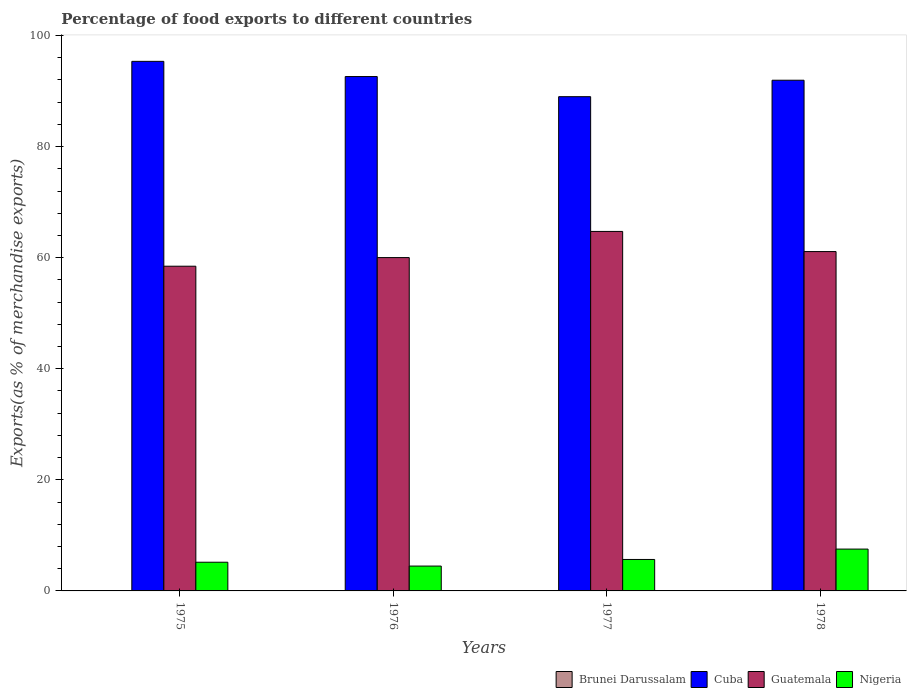How many groups of bars are there?
Provide a short and direct response. 4. Are the number of bars per tick equal to the number of legend labels?
Provide a short and direct response. Yes. Are the number of bars on each tick of the X-axis equal?
Give a very brief answer. Yes. What is the label of the 4th group of bars from the left?
Ensure brevity in your answer.  1978. In how many cases, is the number of bars for a given year not equal to the number of legend labels?
Ensure brevity in your answer.  0. What is the percentage of exports to different countries in Cuba in 1977?
Offer a terse response. 88.99. Across all years, what is the maximum percentage of exports to different countries in Brunei Darussalam?
Ensure brevity in your answer.  0.06. Across all years, what is the minimum percentage of exports to different countries in Cuba?
Make the answer very short. 88.99. In which year was the percentage of exports to different countries in Cuba maximum?
Provide a succinct answer. 1975. In which year was the percentage of exports to different countries in Nigeria minimum?
Provide a short and direct response. 1976. What is the total percentage of exports to different countries in Nigeria in the graph?
Offer a very short reply. 22.84. What is the difference between the percentage of exports to different countries in Cuba in 1975 and that in 1976?
Provide a short and direct response. 2.74. What is the difference between the percentage of exports to different countries in Brunei Darussalam in 1975 and the percentage of exports to different countries in Cuba in 1978?
Give a very brief answer. -91.89. What is the average percentage of exports to different countries in Cuba per year?
Your answer should be very brief. 92.23. In the year 1975, what is the difference between the percentage of exports to different countries in Guatemala and percentage of exports to different countries in Brunei Darussalam?
Your answer should be very brief. 58.4. In how many years, is the percentage of exports to different countries in Cuba greater than 40 %?
Your answer should be very brief. 4. What is the ratio of the percentage of exports to different countries in Guatemala in 1976 to that in 1978?
Offer a terse response. 0.98. Is the difference between the percentage of exports to different countries in Guatemala in 1975 and 1978 greater than the difference between the percentage of exports to different countries in Brunei Darussalam in 1975 and 1978?
Ensure brevity in your answer.  No. What is the difference between the highest and the second highest percentage of exports to different countries in Cuba?
Offer a terse response. 2.74. What is the difference between the highest and the lowest percentage of exports to different countries in Nigeria?
Give a very brief answer. 3.06. In how many years, is the percentage of exports to different countries in Cuba greater than the average percentage of exports to different countries in Cuba taken over all years?
Your answer should be very brief. 2. Is it the case that in every year, the sum of the percentage of exports to different countries in Guatemala and percentage of exports to different countries in Brunei Darussalam is greater than the sum of percentage of exports to different countries in Cuba and percentage of exports to different countries in Nigeria?
Offer a terse response. Yes. What does the 4th bar from the left in 1978 represents?
Provide a succinct answer. Nigeria. What does the 1st bar from the right in 1975 represents?
Offer a terse response. Nigeria. Is it the case that in every year, the sum of the percentage of exports to different countries in Guatemala and percentage of exports to different countries in Brunei Darussalam is greater than the percentage of exports to different countries in Nigeria?
Provide a succinct answer. Yes. How many bars are there?
Ensure brevity in your answer.  16. How many years are there in the graph?
Your answer should be compact. 4. Are the values on the major ticks of Y-axis written in scientific E-notation?
Make the answer very short. No. How many legend labels are there?
Your answer should be compact. 4. What is the title of the graph?
Provide a short and direct response. Percentage of food exports to different countries. What is the label or title of the X-axis?
Your response must be concise. Years. What is the label or title of the Y-axis?
Your response must be concise. Exports(as % of merchandise exports). What is the Exports(as % of merchandise exports) of Brunei Darussalam in 1975?
Make the answer very short. 0.06. What is the Exports(as % of merchandise exports) of Cuba in 1975?
Offer a very short reply. 95.35. What is the Exports(as % of merchandise exports) of Guatemala in 1975?
Make the answer very short. 58.47. What is the Exports(as % of merchandise exports) of Nigeria in 1975?
Your response must be concise. 5.17. What is the Exports(as % of merchandise exports) in Brunei Darussalam in 1976?
Provide a succinct answer. 0.04. What is the Exports(as % of merchandise exports) of Cuba in 1976?
Your answer should be compact. 92.62. What is the Exports(as % of merchandise exports) of Guatemala in 1976?
Offer a terse response. 60.02. What is the Exports(as % of merchandise exports) of Nigeria in 1976?
Offer a terse response. 4.47. What is the Exports(as % of merchandise exports) of Brunei Darussalam in 1977?
Your answer should be compact. 0.03. What is the Exports(as % of merchandise exports) of Cuba in 1977?
Your answer should be compact. 88.99. What is the Exports(as % of merchandise exports) in Guatemala in 1977?
Make the answer very short. 64.73. What is the Exports(as % of merchandise exports) in Nigeria in 1977?
Your answer should be very brief. 5.66. What is the Exports(as % of merchandise exports) of Brunei Darussalam in 1978?
Provide a succinct answer. 0.01. What is the Exports(as % of merchandise exports) of Cuba in 1978?
Keep it short and to the point. 91.95. What is the Exports(as % of merchandise exports) of Guatemala in 1978?
Provide a succinct answer. 61.1. What is the Exports(as % of merchandise exports) of Nigeria in 1978?
Ensure brevity in your answer.  7.53. Across all years, what is the maximum Exports(as % of merchandise exports) of Brunei Darussalam?
Ensure brevity in your answer.  0.06. Across all years, what is the maximum Exports(as % of merchandise exports) of Cuba?
Keep it short and to the point. 95.35. Across all years, what is the maximum Exports(as % of merchandise exports) of Guatemala?
Give a very brief answer. 64.73. Across all years, what is the maximum Exports(as % of merchandise exports) of Nigeria?
Provide a short and direct response. 7.53. Across all years, what is the minimum Exports(as % of merchandise exports) in Brunei Darussalam?
Make the answer very short. 0.01. Across all years, what is the minimum Exports(as % of merchandise exports) in Cuba?
Your answer should be very brief. 88.99. Across all years, what is the minimum Exports(as % of merchandise exports) of Guatemala?
Your answer should be very brief. 58.47. Across all years, what is the minimum Exports(as % of merchandise exports) of Nigeria?
Your answer should be compact. 4.47. What is the total Exports(as % of merchandise exports) of Brunei Darussalam in the graph?
Provide a succinct answer. 0.14. What is the total Exports(as % of merchandise exports) in Cuba in the graph?
Offer a terse response. 368.91. What is the total Exports(as % of merchandise exports) in Guatemala in the graph?
Keep it short and to the point. 244.32. What is the total Exports(as % of merchandise exports) of Nigeria in the graph?
Keep it short and to the point. 22.84. What is the difference between the Exports(as % of merchandise exports) of Brunei Darussalam in 1975 and that in 1976?
Your response must be concise. 0.03. What is the difference between the Exports(as % of merchandise exports) of Cuba in 1975 and that in 1976?
Your answer should be compact. 2.74. What is the difference between the Exports(as % of merchandise exports) of Guatemala in 1975 and that in 1976?
Provide a succinct answer. -1.55. What is the difference between the Exports(as % of merchandise exports) in Nigeria in 1975 and that in 1976?
Give a very brief answer. 0.69. What is the difference between the Exports(as % of merchandise exports) of Brunei Darussalam in 1975 and that in 1977?
Offer a very short reply. 0.04. What is the difference between the Exports(as % of merchandise exports) in Cuba in 1975 and that in 1977?
Your response must be concise. 6.36. What is the difference between the Exports(as % of merchandise exports) in Guatemala in 1975 and that in 1977?
Your response must be concise. -6.26. What is the difference between the Exports(as % of merchandise exports) of Nigeria in 1975 and that in 1977?
Ensure brevity in your answer.  -0.5. What is the difference between the Exports(as % of merchandise exports) in Brunei Darussalam in 1975 and that in 1978?
Your response must be concise. 0.05. What is the difference between the Exports(as % of merchandise exports) of Cuba in 1975 and that in 1978?
Provide a succinct answer. 3.4. What is the difference between the Exports(as % of merchandise exports) of Guatemala in 1975 and that in 1978?
Ensure brevity in your answer.  -2.64. What is the difference between the Exports(as % of merchandise exports) of Nigeria in 1975 and that in 1978?
Ensure brevity in your answer.  -2.37. What is the difference between the Exports(as % of merchandise exports) in Brunei Darussalam in 1976 and that in 1977?
Provide a short and direct response. 0.01. What is the difference between the Exports(as % of merchandise exports) of Cuba in 1976 and that in 1977?
Your response must be concise. 3.62. What is the difference between the Exports(as % of merchandise exports) of Guatemala in 1976 and that in 1977?
Your answer should be compact. -4.71. What is the difference between the Exports(as % of merchandise exports) in Nigeria in 1976 and that in 1977?
Offer a very short reply. -1.19. What is the difference between the Exports(as % of merchandise exports) of Brunei Darussalam in 1976 and that in 1978?
Keep it short and to the point. 0.02. What is the difference between the Exports(as % of merchandise exports) of Cuba in 1976 and that in 1978?
Your answer should be compact. 0.66. What is the difference between the Exports(as % of merchandise exports) of Guatemala in 1976 and that in 1978?
Your answer should be compact. -1.08. What is the difference between the Exports(as % of merchandise exports) in Nigeria in 1976 and that in 1978?
Offer a terse response. -3.06. What is the difference between the Exports(as % of merchandise exports) of Brunei Darussalam in 1977 and that in 1978?
Your answer should be very brief. 0.01. What is the difference between the Exports(as % of merchandise exports) in Cuba in 1977 and that in 1978?
Give a very brief answer. -2.96. What is the difference between the Exports(as % of merchandise exports) of Guatemala in 1977 and that in 1978?
Give a very brief answer. 3.62. What is the difference between the Exports(as % of merchandise exports) of Nigeria in 1977 and that in 1978?
Keep it short and to the point. -1.87. What is the difference between the Exports(as % of merchandise exports) in Brunei Darussalam in 1975 and the Exports(as % of merchandise exports) in Cuba in 1976?
Your answer should be very brief. -92.55. What is the difference between the Exports(as % of merchandise exports) in Brunei Darussalam in 1975 and the Exports(as % of merchandise exports) in Guatemala in 1976?
Provide a succinct answer. -59.96. What is the difference between the Exports(as % of merchandise exports) in Brunei Darussalam in 1975 and the Exports(as % of merchandise exports) in Nigeria in 1976?
Provide a short and direct response. -4.41. What is the difference between the Exports(as % of merchandise exports) of Cuba in 1975 and the Exports(as % of merchandise exports) of Guatemala in 1976?
Give a very brief answer. 35.33. What is the difference between the Exports(as % of merchandise exports) in Cuba in 1975 and the Exports(as % of merchandise exports) in Nigeria in 1976?
Your response must be concise. 90.88. What is the difference between the Exports(as % of merchandise exports) in Guatemala in 1975 and the Exports(as % of merchandise exports) in Nigeria in 1976?
Make the answer very short. 53.99. What is the difference between the Exports(as % of merchandise exports) of Brunei Darussalam in 1975 and the Exports(as % of merchandise exports) of Cuba in 1977?
Keep it short and to the point. -88.93. What is the difference between the Exports(as % of merchandise exports) of Brunei Darussalam in 1975 and the Exports(as % of merchandise exports) of Guatemala in 1977?
Offer a terse response. -64.66. What is the difference between the Exports(as % of merchandise exports) in Brunei Darussalam in 1975 and the Exports(as % of merchandise exports) in Nigeria in 1977?
Your answer should be compact. -5.6. What is the difference between the Exports(as % of merchandise exports) in Cuba in 1975 and the Exports(as % of merchandise exports) in Guatemala in 1977?
Provide a short and direct response. 30.62. What is the difference between the Exports(as % of merchandise exports) of Cuba in 1975 and the Exports(as % of merchandise exports) of Nigeria in 1977?
Make the answer very short. 89.69. What is the difference between the Exports(as % of merchandise exports) of Guatemala in 1975 and the Exports(as % of merchandise exports) of Nigeria in 1977?
Offer a very short reply. 52.8. What is the difference between the Exports(as % of merchandise exports) in Brunei Darussalam in 1975 and the Exports(as % of merchandise exports) in Cuba in 1978?
Ensure brevity in your answer.  -91.89. What is the difference between the Exports(as % of merchandise exports) in Brunei Darussalam in 1975 and the Exports(as % of merchandise exports) in Guatemala in 1978?
Ensure brevity in your answer.  -61.04. What is the difference between the Exports(as % of merchandise exports) in Brunei Darussalam in 1975 and the Exports(as % of merchandise exports) in Nigeria in 1978?
Your answer should be compact. -7.47. What is the difference between the Exports(as % of merchandise exports) in Cuba in 1975 and the Exports(as % of merchandise exports) in Guatemala in 1978?
Your response must be concise. 34.25. What is the difference between the Exports(as % of merchandise exports) of Cuba in 1975 and the Exports(as % of merchandise exports) of Nigeria in 1978?
Provide a short and direct response. 87.82. What is the difference between the Exports(as % of merchandise exports) of Guatemala in 1975 and the Exports(as % of merchandise exports) of Nigeria in 1978?
Your answer should be very brief. 50.94. What is the difference between the Exports(as % of merchandise exports) of Brunei Darussalam in 1976 and the Exports(as % of merchandise exports) of Cuba in 1977?
Your answer should be very brief. -88.96. What is the difference between the Exports(as % of merchandise exports) in Brunei Darussalam in 1976 and the Exports(as % of merchandise exports) in Guatemala in 1977?
Your answer should be very brief. -64.69. What is the difference between the Exports(as % of merchandise exports) of Brunei Darussalam in 1976 and the Exports(as % of merchandise exports) of Nigeria in 1977?
Offer a terse response. -5.63. What is the difference between the Exports(as % of merchandise exports) of Cuba in 1976 and the Exports(as % of merchandise exports) of Guatemala in 1977?
Your response must be concise. 27.89. What is the difference between the Exports(as % of merchandise exports) of Cuba in 1976 and the Exports(as % of merchandise exports) of Nigeria in 1977?
Your answer should be compact. 86.95. What is the difference between the Exports(as % of merchandise exports) in Guatemala in 1976 and the Exports(as % of merchandise exports) in Nigeria in 1977?
Provide a short and direct response. 54.36. What is the difference between the Exports(as % of merchandise exports) in Brunei Darussalam in 1976 and the Exports(as % of merchandise exports) in Cuba in 1978?
Ensure brevity in your answer.  -91.92. What is the difference between the Exports(as % of merchandise exports) in Brunei Darussalam in 1976 and the Exports(as % of merchandise exports) in Guatemala in 1978?
Provide a succinct answer. -61.07. What is the difference between the Exports(as % of merchandise exports) in Brunei Darussalam in 1976 and the Exports(as % of merchandise exports) in Nigeria in 1978?
Your answer should be very brief. -7.5. What is the difference between the Exports(as % of merchandise exports) in Cuba in 1976 and the Exports(as % of merchandise exports) in Guatemala in 1978?
Provide a short and direct response. 31.51. What is the difference between the Exports(as % of merchandise exports) of Cuba in 1976 and the Exports(as % of merchandise exports) of Nigeria in 1978?
Provide a succinct answer. 85.08. What is the difference between the Exports(as % of merchandise exports) in Guatemala in 1976 and the Exports(as % of merchandise exports) in Nigeria in 1978?
Your answer should be very brief. 52.49. What is the difference between the Exports(as % of merchandise exports) in Brunei Darussalam in 1977 and the Exports(as % of merchandise exports) in Cuba in 1978?
Make the answer very short. -91.92. What is the difference between the Exports(as % of merchandise exports) in Brunei Darussalam in 1977 and the Exports(as % of merchandise exports) in Guatemala in 1978?
Your answer should be compact. -61.08. What is the difference between the Exports(as % of merchandise exports) in Brunei Darussalam in 1977 and the Exports(as % of merchandise exports) in Nigeria in 1978?
Make the answer very short. -7.5. What is the difference between the Exports(as % of merchandise exports) in Cuba in 1977 and the Exports(as % of merchandise exports) in Guatemala in 1978?
Offer a terse response. 27.89. What is the difference between the Exports(as % of merchandise exports) of Cuba in 1977 and the Exports(as % of merchandise exports) of Nigeria in 1978?
Provide a short and direct response. 81.46. What is the difference between the Exports(as % of merchandise exports) in Guatemala in 1977 and the Exports(as % of merchandise exports) in Nigeria in 1978?
Make the answer very short. 57.2. What is the average Exports(as % of merchandise exports) in Brunei Darussalam per year?
Offer a very short reply. 0.04. What is the average Exports(as % of merchandise exports) of Cuba per year?
Your answer should be compact. 92.23. What is the average Exports(as % of merchandise exports) in Guatemala per year?
Make the answer very short. 61.08. What is the average Exports(as % of merchandise exports) in Nigeria per year?
Offer a terse response. 5.71. In the year 1975, what is the difference between the Exports(as % of merchandise exports) in Brunei Darussalam and Exports(as % of merchandise exports) in Cuba?
Offer a very short reply. -95.29. In the year 1975, what is the difference between the Exports(as % of merchandise exports) in Brunei Darussalam and Exports(as % of merchandise exports) in Guatemala?
Provide a short and direct response. -58.4. In the year 1975, what is the difference between the Exports(as % of merchandise exports) in Brunei Darussalam and Exports(as % of merchandise exports) in Nigeria?
Keep it short and to the point. -5.1. In the year 1975, what is the difference between the Exports(as % of merchandise exports) of Cuba and Exports(as % of merchandise exports) of Guatemala?
Offer a very short reply. 36.88. In the year 1975, what is the difference between the Exports(as % of merchandise exports) in Cuba and Exports(as % of merchandise exports) in Nigeria?
Make the answer very short. 90.19. In the year 1975, what is the difference between the Exports(as % of merchandise exports) in Guatemala and Exports(as % of merchandise exports) in Nigeria?
Make the answer very short. 53.3. In the year 1976, what is the difference between the Exports(as % of merchandise exports) in Brunei Darussalam and Exports(as % of merchandise exports) in Cuba?
Offer a very short reply. -92.58. In the year 1976, what is the difference between the Exports(as % of merchandise exports) of Brunei Darussalam and Exports(as % of merchandise exports) of Guatemala?
Ensure brevity in your answer.  -59.98. In the year 1976, what is the difference between the Exports(as % of merchandise exports) of Brunei Darussalam and Exports(as % of merchandise exports) of Nigeria?
Offer a very short reply. -4.44. In the year 1976, what is the difference between the Exports(as % of merchandise exports) of Cuba and Exports(as % of merchandise exports) of Guatemala?
Keep it short and to the point. 32.6. In the year 1976, what is the difference between the Exports(as % of merchandise exports) of Cuba and Exports(as % of merchandise exports) of Nigeria?
Keep it short and to the point. 88.14. In the year 1976, what is the difference between the Exports(as % of merchandise exports) in Guatemala and Exports(as % of merchandise exports) in Nigeria?
Your answer should be compact. 55.55. In the year 1977, what is the difference between the Exports(as % of merchandise exports) of Brunei Darussalam and Exports(as % of merchandise exports) of Cuba?
Your response must be concise. -88.96. In the year 1977, what is the difference between the Exports(as % of merchandise exports) in Brunei Darussalam and Exports(as % of merchandise exports) in Guatemala?
Provide a succinct answer. -64.7. In the year 1977, what is the difference between the Exports(as % of merchandise exports) in Brunei Darussalam and Exports(as % of merchandise exports) in Nigeria?
Your answer should be compact. -5.64. In the year 1977, what is the difference between the Exports(as % of merchandise exports) of Cuba and Exports(as % of merchandise exports) of Guatemala?
Keep it short and to the point. 24.26. In the year 1977, what is the difference between the Exports(as % of merchandise exports) in Cuba and Exports(as % of merchandise exports) in Nigeria?
Offer a very short reply. 83.33. In the year 1977, what is the difference between the Exports(as % of merchandise exports) of Guatemala and Exports(as % of merchandise exports) of Nigeria?
Give a very brief answer. 59.06. In the year 1978, what is the difference between the Exports(as % of merchandise exports) in Brunei Darussalam and Exports(as % of merchandise exports) in Cuba?
Give a very brief answer. -91.94. In the year 1978, what is the difference between the Exports(as % of merchandise exports) of Brunei Darussalam and Exports(as % of merchandise exports) of Guatemala?
Offer a terse response. -61.09. In the year 1978, what is the difference between the Exports(as % of merchandise exports) of Brunei Darussalam and Exports(as % of merchandise exports) of Nigeria?
Ensure brevity in your answer.  -7.52. In the year 1978, what is the difference between the Exports(as % of merchandise exports) in Cuba and Exports(as % of merchandise exports) in Guatemala?
Provide a short and direct response. 30.85. In the year 1978, what is the difference between the Exports(as % of merchandise exports) of Cuba and Exports(as % of merchandise exports) of Nigeria?
Your answer should be compact. 84.42. In the year 1978, what is the difference between the Exports(as % of merchandise exports) of Guatemala and Exports(as % of merchandise exports) of Nigeria?
Give a very brief answer. 53.57. What is the ratio of the Exports(as % of merchandise exports) of Brunei Darussalam in 1975 to that in 1976?
Your answer should be very brief. 1.79. What is the ratio of the Exports(as % of merchandise exports) in Cuba in 1975 to that in 1976?
Make the answer very short. 1.03. What is the ratio of the Exports(as % of merchandise exports) of Guatemala in 1975 to that in 1976?
Ensure brevity in your answer.  0.97. What is the ratio of the Exports(as % of merchandise exports) of Nigeria in 1975 to that in 1976?
Offer a very short reply. 1.15. What is the ratio of the Exports(as % of merchandise exports) in Brunei Darussalam in 1975 to that in 1977?
Keep it short and to the point. 2.26. What is the ratio of the Exports(as % of merchandise exports) in Cuba in 1975 to that in 1977?
Offer a very short reply. 1.07. What is the ratio of the Exports(as % of merchandise exports) of Guatemala in 1975 to that in 1977?
Your answer should be compact. 0.9. What is the ratio of the Exports(as % of merchandise exports) of Nigeria in 1975 to that in 1977?
Provide a succinct answer. 0.91. What is the ratio of the Exports(as % of merchandise exports) of Brunei Darussalam in 1975 to that in 1978?
Provide a short and direct response. 4.75. What is the ratio of the Exports(as % of merchandise exports) of Cuba in 1975 to that in 1978?
Ensure brevity in your answer.  1.04. What is the ratio of the Exports(as % of merchandise exports) of Guatemala in 1975 to that in 1978?
Make the answer very short. 0.96. What is the ratio of the Exports(as % of merchandise exports) in Nigeria in 1975 to that in 1978?
Your response must be concise. 0.69. What is the ratio of the Exports(as % of merchandise exports) in Brunei Darussalam in 1976 to that in 1977?
Your answer should be compact. 1.26. What is the ratio of the Exports(as % of merchandise exports) in Cuba in 1976 to that in 1977?
Keep it short and to the point. 1.04. What is the ratio of the Exports(as % of merchandise exports) in Guatemala in 1976 to that in 1977?
Provide a succinct answer. 0.93. What is the ratio of the Exports(as % of merchandise exports) in Nigeria in 1976 to that in 1977?
Provide a short and direct response. 0.79. What is the ratio of the Exports(as % of merchandise exports) of Brunei Darussalam in 1976 to that in 1978?
Make the answer very short. 2.65. What is the ratio of the Exports(as % of merchandise exports) of Guatemala in 1976 to that in 1978?
Provide a short and direct response. 0.98. What is the ratio of the Exports(as % of merchandise exports) of Nigeria in 1976 to that in 1978?
Offer a terse response. 0.59. What is the ratio of the Exports(as % of merchandise exports) in Brunei Darussalam in 1977 to that in 1978?
Keep it short and to the point. 2.11. What is the ratio of the Exports(as % of merchandise exports) in Cuba in 1977 to that in 1978?
Keep it short and to the point. 0.97. What is the ratio of the Exports(as % of merchandise exports) in Guatemala in 1977 to that in 1978?
Ensure brevity in your answer.  1.06. What is the ratio of the Exports(as % of merchandise exports) in Nigeria in 1977 to that in 1978?
Your answer should be compact. 0.75. What is the difference between the highest and the second highest Exports(as % of merchandise exports) of Brunei Darussalam?
Your response must be concise. 0.03. What is the difference between the highest and the second highest Exports(as % of merchandise exports) in Cuba?
Your answer should be very brief. 2.74. What is the difference between the highest and the second highest Exports(as % of merchandise exports) in Guatemala?
Your answer should be compact. 3.62. What is the difference between the highest and the second highest Exports(as % of merchandise exports) of Nigeria?
Your response must be concise. 1.87. What is the difference between the highest and the lowest Exports(as % of merchandise exports) in Brunei Darussalam?
Provide a short and direct response. 0.05. What is the difference between the highest and the lowest Exports(as % of merchandise exports) of Cuba?
Offer a very short reply. 6.36. What is the difference between the highest and the lowest Exports(as % of merchandise exports) in Guatemala?
Offer a terse response. 6.26. What is the difference between the highest and the lowest Exports(as % of merchandise exports) in Nigeria?
Provide a short and direct response. 3.06. 